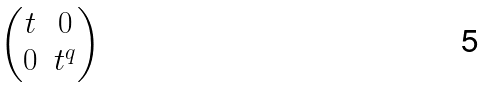Convert formula to latex. <formula><loc_0><loc_0><loc_500><loc_500>\begin{pmatrix} t & 0 \\ 0 & t ^ { q } \end{pmatrix}</formula> 